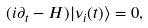<formula> <loc_0><loc_0><loc_500><loc_500>( i \partial _ { t } - H ) | \nu _ { i } ( t ) \rangle = 0 ,</formula> 